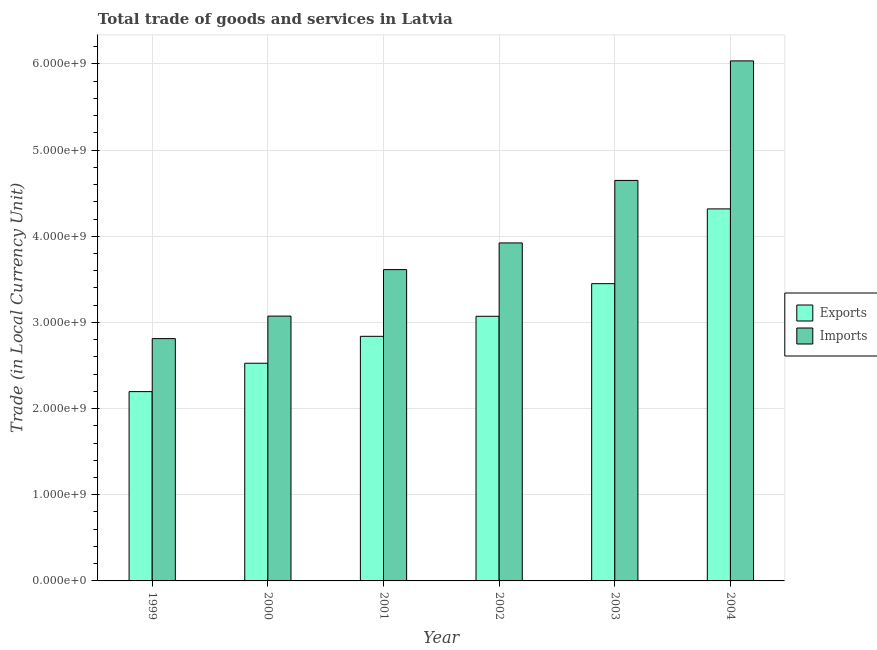How many different coloured bars are there?
Ensure brevity in your answer.  2. Are the number of bars per tick equal to the number of legend labels?
Offer a very short reply. Yes. Are the number of bars on each tick of the X-axis equal?
Your answer should be very brief. Yes. How many bars are there on the 3rd tick from the right?
Your response must be concise. 2. What is the label of the 2nd group of bars from the left?
Your answer should be compact. 2000. In how many cases, is the number of bars for a given year not equal to the number of legend labels?
Provide a succinct answer. 0. What is the export of goods and services in 2004?
Provide a short and direct response. 4.32e+09. Across all years, what is the maximum export of goods and services?
Offer a terse response. 4.32e+09. Across all years, what is the minimum imports of goods and services?
Your answer should be very brief. 2.81e+09. In which year was the imports of goods and services maximum?
Your answer should be very brief. 2004. In which year was the imports of goods and services minimum?
Offer a terse response. 1999. What is the total export of goods and services in the graph?
Offer a very short reply. 1.84e+1. What is the difference between the export of goods and services in 1999 and that in 2003?
Provide a short and direct response. -1.25e+09. What is the difference between the export of goods and services in 2001 and the imports of goods and services in 2003?
Your response must be concise. -6.11e+08. What is the average export of goods and services per year?
Your answer should be compact. 3.07e+09. In the year 1999, what is the difference between the imports of goods and services and export of goods and services?
Keep it short and to the point. 0. In how many years, is the export of goods and services greater than 1600000000 LCU?
Your answer should be compact. 6. What is the ratio of the export of goods and services in 2001 to that in 2002?
Give a very brief answer. 0.92. Is the difference between the imports of goods and services in 1999 and 2002 greater than the difference between the export of goods and services in 1999 and 2002?
Provide a succinct answer. No. What is the difference between the highest and the second highest imports of goods and services?
Keep it short and to the point. 1.39e+09. What is the difference between the highest and the lowest export of goods and services?
Provide a succinct answer. 2.12e+09. In how many years, is the export of goods and services greater than the average export of goods and services taken over all years?
Provide a succinct answer. 3. What does the 2nd bar from the left in 2000 represents?
Your answer should be very brief. Imports. What does the 2nd bar from the right in 2001 represents?
Offer a terse response. Exports. Are all the bars in the graph horizontal?
Provide a succinct answer. No. How many years are there in the graph?
Make the answer very short. 6. What is the difference between two consecutive major ticks on the Y-axis?
Offer a very short reply. 1.00e+09. Does the graph contain grids?
Provide a succinct answer. Yes. What is the title of the graph?
Make the answer very short. Total trade of goods and services in Latvia. Does "All education staff compensation" appear as one of the legend labels in the graph?
Give a very brief answer. No. What is the label or title of the Y-axis?
Offer a terse response. Trade (in Local Currency Unit). What is the Trade (in Local Currency Unit) in Exports in 1999?
Provide a succinct answer. 2.20e+09. What is the Trade (in Local Currency Unit) in Imports in 1999?
Keep it short and to the point. 2.81e+09. What is the Trade (in Local Currency Unit) in Exports in 2000?
Offer a terse response. 2.53e+09. What is the Trade (in Local Currency Unit) of Imports in 2000?
Ensure brevity in your answer.  3.07e+09. What is the Trade (in Local Currency Unit) of Exports in 2001?
Offer a terse response. 2.84e+09. What is the Trade (in Local Currency Unit) of Imports in 2001?
Provide a succinct answer. 3.61e+09. What is the Trade (in Local Currency Unit) of Exports in 2002?
Your answer should be very brief. 3.07e+09. What is the Trade (in Local Currency Unit) in Imports in 2002?
Offer a terse response. 3.92e+09. What is the Trade (in Local Currency Unit) of Exports in 2003?
Your answer should be compact. 3.45e+09. What is the Trade (in Local Currency Unit) of Imports in 2003?
Your answer should be very brief. 4.65e+09. What is the Trade (in Local Currency Unit) in Exports in 2004?
Ensure brevity in your answer.  4.32e+09. What is the Trade (in Local Currency Unit) of Imports in 2004?
Make the answer very short. 6.04e+09. Across all years, what is the maximum Trade (in Local Currency Unit) in Exports?
Provide a succinct answer. 4.32e+09. Across all years, what is the maximum Trade (in Local Currency Unit) in Imports?
Give a very brief answer. 6.04e+09. Across all years, what is the minimum Trade (in Local Currency Unit) of Exports?
Provide a short and direct response. 2.20e+09. Across all years, what is the minimum Trade (in Local Currency Unit) of Imports?
Give a very brief answer. 2.81e+09. What is the total Trade (in Local Currency Unit) of Exports in the graph?
Make the answer very short. 1.84e+1. What is the total Trade (in Local Currency Unit) of Imports in the graph?
Keep it short and to the point. 2.41e+1. What is the difference between the Trade (in Local Currency Unit) in Exports in 1999 and that in 2000?
Your answer should be very brief. -3.29e+08. What is the difference between the Trade (in Local Currency Unit) of Imports in 1999 and that in 2000?
Provide a short and direct response. -2.61e+08. What is the difference between the Trade (in Local Currency Unit) of Exports in 1999 and that in 2001?
Your answer should be compact. -6.42e+08. What is the difference between the Trade (in Local Currency Unit) in Imports in 1999 and that in 2001?
Give a very brief answer. -8.01e+08. What is the difference between the Trade (in Local Currency Unit) in Exports in 1999 and that in 2002?
Keep it short and to the point. -8.74e+08. What is the difference between the Trade (in Local Currency Unit) of Imports in 1999 and that in 2002?
Your response must be concise. -1.11e+09. What is the difference between the Trade (in Local Currency Unit) in Exports in 1999 and that in 2003?
Offer a very short reply. -1.25e+09. What is the difference between the Trade (in Local Currency Unit) of Imports in 1999 and that in 2003?
Provide a short and direct response. -1.84e+09. What is the difference between the Trade (in Local Currency Unit) in Exports in 1999 and that in 2004?
Offer a very short reply. -2.12e+09. What is the difference between the Trade (in Local Currency Unit) in Imports in 1999 and that in 2004?
Ensure brevity in your answer.  -3.22e+09. What is the difference between the Trade (in Local Currency Unit) in Exports in 2000 and that in 2001?
Your response must be concise. -3.12e+08. What is the difference between the Trade (in Local Currency Unit) of Imports in 2000 and that in 2001?
Offer a terse response. -5.40e+08. What is the difference between the Trade (in Local Currency Unit) of Exports in 2000 and that in 2002?
Provide a succinct answer. -5.45e+08. What is the difference between the Trade (in Local Currency Unit) of Imports in 2000 and that in 2002?
Ensure brevity in your answer.  -8.49e+08. What is the difference between the Trade (in Local Currency Unit) of Exports in 2000 and that in 2003?
Provide a succinct answer. -9.24e+08. What is the difference between the Trade (in Local Currency Unit) in Imports in 2000 and that in 2003?
Make the answer very short. -1.57e+09. What is the difference between the Trade (in Local Currency Unit) in Exports in 2000 and that in 2004?
Offer a terse response. -1.79e+09. What is the difference between the Trade (in Local Currency Unit) of Imports in 2000 and that in 2004?
Make the answer very short. -2.96e+09. What is the difference between the Trade (in Local Currency Unit) in Exports in 2001 and that in 2002?
Your answer should be compact. -2.33e+08. What is the difference between the Trade (in Local Currency Unit) in Imports in 2001 and that in 2002?
Your response must be concise. -3.09e+08. What is the difference between the Trade (in Local Currency Unit) in Exports in 2001 and that in 2003?
Provide a succinct answer. -6.11e+08. What is the difference between the Trade (in Local Currency Unit) of Imports in 2001 and that in 2003?
Your answer should be very brief. -1.03e+09. What is the difference between the Trade (in Local Currency Unit) of Exports in 2001 and that in 2004?
Give a very brief answer. -1.48e+09. What is the difference between the Trade (in Local Currency Unit) in Imports in 2001 and that in 2004?
Your answer should be compact. -2.42e+09. What is the difference between the Trade (in Local Currency Unit) in Exports in 2002 and that in 2003?
Your answer should be compact. -3.79e+08. What is the difference between the Trade (in Local Currency Unit) of Imports in 2002 and that in 2003?
Provide a succinct answer. -7.26e+08. What is the difference between the Trade (in Local Currency Unit) in Exports in 2002 and that in 2004?
Offer a very short reply. -1.25e+09. What is the difference between the Trade (in Local Currency Unit) of Imports in 2002 and that in 2004?
Your answer should be compact. -2.11e+09. What is the difference between the Trade (in Local Currency Unit) of Exports in 2003 and that in 2004?
Your answer should be compact. -8.68e+08. What is the difference between the Trade (in Local Currency Unit) of Imports in 2003 and that in 2004?
Your response must be concise. -1.39e+09. What is the difference between the Trade (in Local Currency Unit) of Exports in 1999 and the Trade (in Local Currency Unit) of Imports in 2000?
Keep it short and to the point. -8.77e+08. What is the difference between the Trade (in Local Currency Unit) of Exports in 1999 and the Trade (in Local Currency Unit) of Imports in 2001?
Keep it short and to the point. -1.42e+09. What is the difference between the Trade (in Local Currency Unit) in Exports in 1999 and the Trade (in Local Currency Unit) in Imports in 2002?
Your answer should be very brief. -1.73e+09. What is the difference between the Trade (in Local Currency Unit) of Exports in 1999 and the Trade (in Local Currency Unit) of Imports in 2003?
Ensure brevity in your answer.  -2.45e+09. What is the difference between the Trade (in Local Currency Unit) in Exports in 1999 and the Trade (in Local Currency Unit) in Imports in 2004?
Your answer should be compact. -3.84e+09. What is the difference between the Trade (in Local Currency Unit) of Exports in 2000 and the Trade (in Local Currency Unit) of Imports in 2001?
Provide a succinct answer. -1.09e+09. What is the difference between the Trade (in Local Currency Unit) of Exports in 2000 and the Trade (in Local Currency Unit) of Imports in 2002?
Make the answer very short. -1.40e+09. What is the difference between the Trade (in Local Currency Unit) of Exports in 2000 and the Trade (in Local Currency Unit) of Imports in 2003?
Make the answer very short. -2.12e+09. What is the difference between the Trade (in Local Currency Unit) of Exports in 2000 and the Trade (in Local Currency Unit) of Imports in 2004?
Offer a very short reply. -3.51e+09. What is the difference between the Trade (in Local Currency Unit) of Exports in 2001 and the Trade (in Local Currency Unit) of Imports in 2002?
Offer a terse response. -1.08e+09. What is the difference between the Trade (in Local Currency Unit) in Exports in 2001 and the Trade (in Local Currency Unit) in Imports in 2003?
Your response must be concise. -1.81e+09. What is the difference between the Trade (in Local Currency Unit) of Exports in 2001 and the Trade (in Local Currency Unit) of Imports in 2004?
Give a very brief answer. -3.20e+09. What is the difference between the Trade (in Local Currency Unit) of Exports in 2002 and the Trade (in Local Currency Unit) of Imports in 2003?
Provide a succinct answer. -1.58e+09. What is the difference between the Trade (in Local Currency Unit) of Exports in 2002 and the Trade (in Local Currency Unit) of Imports in 2004?
Offer a terse response. -2.96e+09. What is the difference between the Trade (in Local Currency Unit) of Exports in 2003 and the Trade (in Local Currency Unit) of Imports in 2004?
Offer a terse response. -2.59e+09. What is the average Trade (in Local Currency Unit) of Exports per year?
Ensure brevity in your answer.  3.07e+09. What is the average Trade (in Local Currency Unit) in Imports per year?
Provide a succinct answer. 4.02e+09. In the year 1999, what is the difference between the Trade (in Local Currency Unit) of Exports and Trade (in Local Currency Unit) of Imports?
Ensure brevity in your answer.  -6.15e+08. In the year 2000, what is the difference between the Trade (in Local Currency Unit) of Exports and Trade (in Local Currency Unit) of Imports?
Your answer should be very brief. -5.47e+08. In the year 2001, what is the difference between the Trade (in Local Currency Unit) in Exports and Trade (in Local Currency Unit) in Imports?
Keep it short and to the point. -7.75e+08. In the year 2002, what is the difference between the Trade (in Local Currency Unit) of Exports and Trade (in Local Currency Unit) of Imports?
Give a very brief answer. -8.51e+08. In the year 2003, what is the difference between the Trade (in Local Currency Unit) in Exports and Trade (in Local Currency Unit) in Imports?
Your response must be concise. -1.20e+09. In the year 2004, what is the difference between the Trade (in Local Currency Unit) of Exports and Trade (in Local Currency Unit) of Imports?
Provide a short and direct response. -1.72e+09. What is the ratio of the Trade (in Local Currency Unit) of Exports in 1999 to that in 2000?
Your response must be concise. 0.87. What is the ratio of the Trade (in Local Currency Unit) of Imports in 1999 to that in 2000?
Offer a terse response. 0.92. What is the ratio of the Trade (in Local Currency Unit) of Exports in 1999 to that in 2001?
Keep it short and to the point. 0.77. What is the ratio of the Trade (in Local Currency Unit) in Imports in 1999 to that in 2001?
Your answer should be compact. 0.78. What is the ratio of the Trade (in Local Currency Unit) in Exports in 1999 to that in 2002?
Provide a succinct answer. 0.72. What is the ratio of the Trade (in Local Currency Unit) in Imports in 1999 to that in 2002?
Offer a terse response. 0.72. What is the ratio of the Trade (in Local Currency Unit) in Exports in 1999 to that in 2003?
Your response must be concise. 0.64. What is the ratio of the Trade (in Local Currency Unit) of Imports in 1999 to that in 2003?
Provide a short and direct response. 0.6. What is the ratio of the Trade (in Local Currency Unit) in Exports in 1999 to that in 2004?
Offer a very short reply. 0.51. What is the ratio of the Trade (in Local Currency Unit) in Imports in 1999 to that in 2004?
Offer a very short reply. 0.47. What is the ratio of the Trade (in Local Currency Unit) of Exports in 2000 to that in 2001?
Provide a short and direct response. 0.89. What is the ratio of the Trade (in Local Currency Unit) of Imports in 2000 to that in 2001?
Your response must be concise. 0.85. What is the ratio of the Trade (in Local Currency Unit) of Exports in 2000 to that in 2002?
Your answer should be compact. 0.82. What is the ratio of the Trade (in Local Currency Unit) of Imports in 2000 to that in 2002?
Offer a terse response. 0.78. What is the ratio of the Trade (in Local Currency Unit) of Exports in 2000 to that in 2003?
Offer a very short reply. 0.73. What is the ratio of the Trade (in Local Currency Unit) in Imports in 2000 to that in 2003?
Make the answer very short. 0.66. What is the ratio of the Trade (in Local Currency Unit) of Exports in 2000 to that in 2004?
Make the answer very short. 0.59. What is the ratio of the Trade (in Local Currency Unit) in Imports in 2000 to that in 2004?
Keep it short and to the point. 0.51. What is the ratio of the Trade (in Local Currency Unit) of Exports in 2001 to that in 2002?
Make the answer very short. 0.92. What is the ratio of the Trade (in Local Currency Unit) of Imports in 2001 to that in 2002?
Your response must be concise. 0.92. What is the ratio of the Trade (in Local Currency Unit) of Exports in 2001 to that in 2003?
Make the answer very short. 0.82. What is the ratio of the Trade (in Local Currency Unit) in Imports in 2001 to that in 2003?
Your response must be concise. 0.78. What is the ratio of the Trade (in Local Currency Unit) in Exports in 2001 to that in 2004?
Offer a very short reply. 0.66. What is the ratio of the Trade (in Local Currency Unit) in Imports in 2001 to that in 2004?
Your answer should be compact. 0.6. What is the ratio of the Trade (in Local Currency Unit) of Exports in 2002 to that in 2003?
Your answer should be very brief. 0.89. What is the ratio of the Trade (in Local Currency Unit) of Imports in 2002 to that in 2003?
Make the answer very short. 0.84. What is the ratio of the Trade (in Local Currency Unit) of Exports in 2002 to that in 2004?
Your answer should be compact. 0.71. What is the ratio of the Trade (in Local Currency Unit) in Imports in 2002 to that in 2004?
Your response must be concise. 0.65. What is the ratio of the Trade (in Local Currency Unit) in Exports in 2003 to that in 2004?
Keep it short and to the point. 0.8. What is the ratio of the Trade (in Local Currency Unit) in Imports in 2003 to that in 2004?
Provide a succinct answer. 0.77. What is the difference between the highest and the second highest Trade (in Local Currency Unit) in Exports?
Make the answer very short. 8.68e+08. What is the difference between the highest and the second highest Trade (in Local Currency Unit) in Imports?
Make the answer very short. 1.39e+09. What is the difference between the highest and the lowest Trade (in Local Currency Unit) of Exports?
Give a very brief answer. 2.12e+09. What is the difference between the highest and the lowest Trade (in Local Currency Unit) in Imports?
Your answer should be compact. 3.22e+09. 